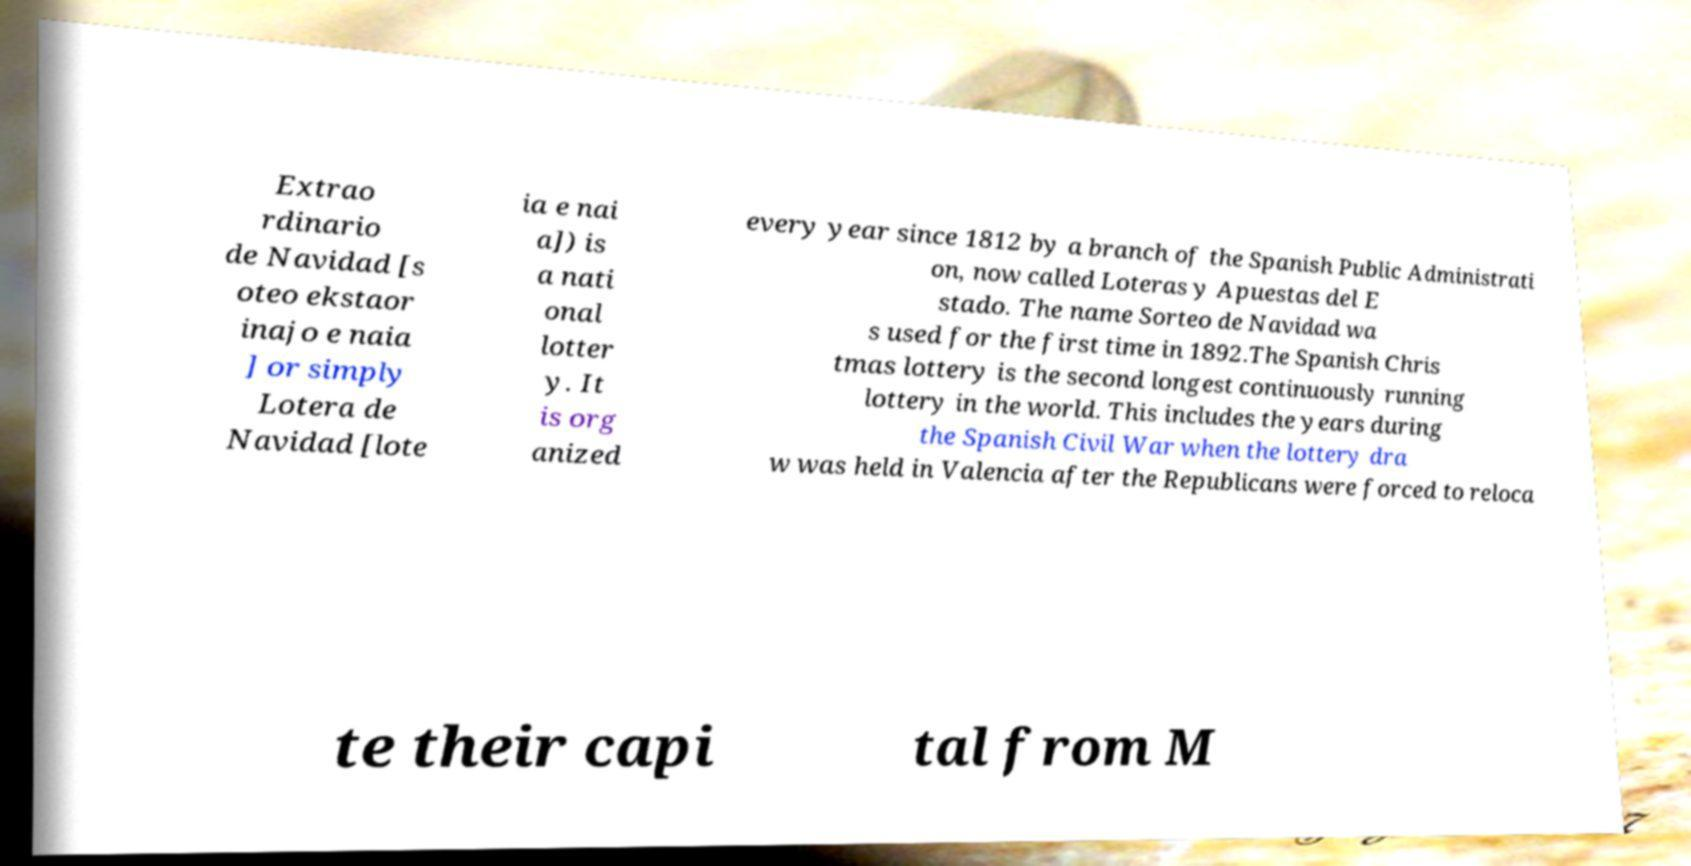Could you assist in decoding the text presented in this image and type it out clearly? Extrao rdinario de Navidad [s oteo ekstaor inajo e naia ] or simply Lotera de Navidad [lote ia e nai a]) is a nati onal lotter y. It is org anized every year since 1812 by a branch of the Spanish Public Administrati on, now called Loteras y Apuestas del E stado. The name Sorteo de Navidad wa s used for the first time in 1892.The Spanish Chris tmas lottery is the second longest continuously running lottery in the world. This includes the years during the Spanish Civil War when the lottery dra w was held in Valencia after the Republicans were forced to reloca te their capi tal from M 